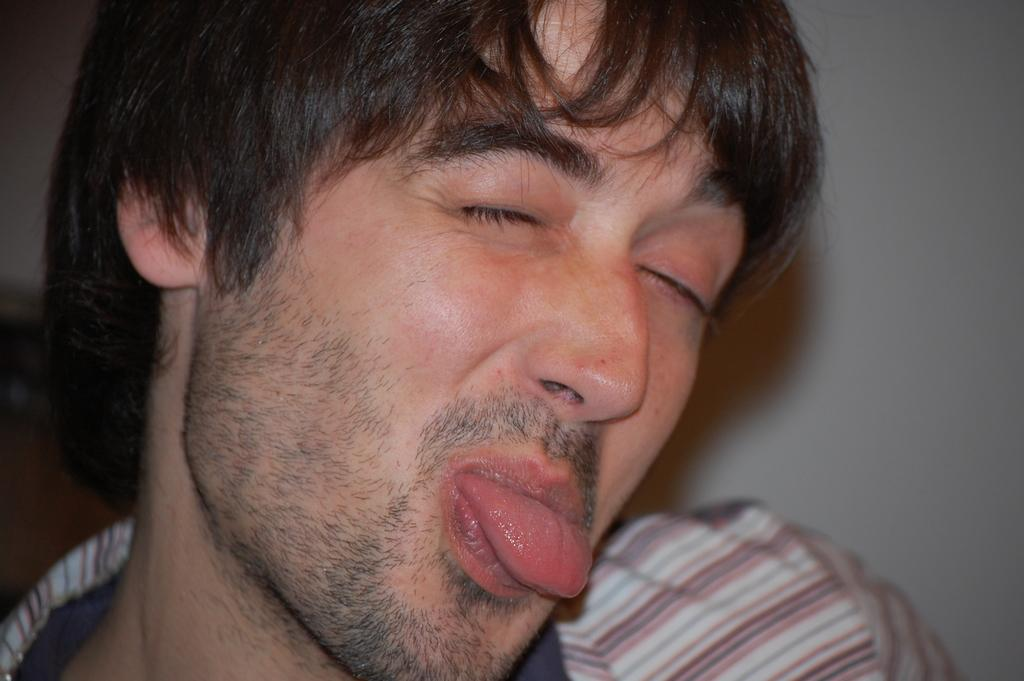What is the main subject of the image? There is a man in the image. What is the man doing in the image? The man has his eyes closed and is sticking his tongue out of his mouth. What can be seen in the background of the image? There is a wall in the background of the image. What type of house is depicted in the image? There is no house depicted in the image; it features a man with his eyes closed and sticking his tongue out. What club does the man belong to in the image? There is no indication of any club or organization in the image; it simply shows a man with his eyes closed and sticking his tongue out. 